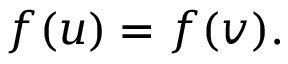Convert formula to latex. <formula><loc_0><loc_0><loc_500><loc_500>f ( u ) = f ( v ) .</formula> 